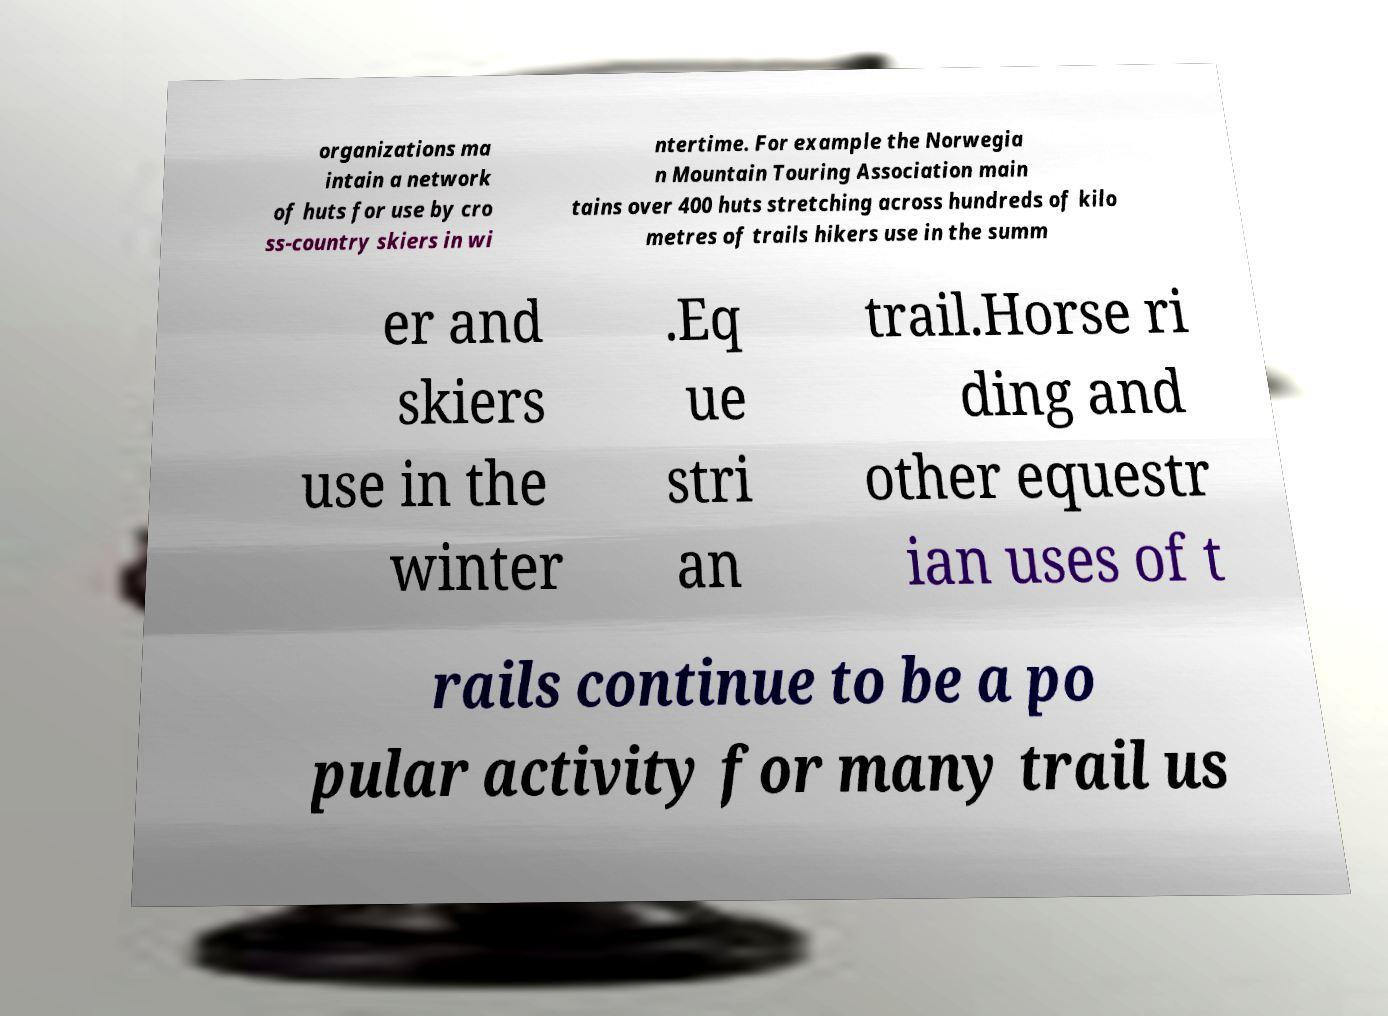Could you assist in decoding the text presented in this image and type it out clearly? organizations ma intain a network of huts for use by cro ss-country skiers in wi ntertime. For example the Norwegia n Mountain Touring Association main tains over 400 huts stretching across hundreds of kilo metres of trails hikers use in the summ er and skiers use in the winter .Eq ue stri an trail.Horse ri ding and other equestr ian uses of t rails continue to be a po pular activity for many trail us 